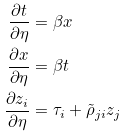<formula> <loc_0><loc_0><loc_500><loc_500>\frac { \partial t } { \partial \eta } & = \beta x \\ \frac { \partial x } { \partial \eta } & = \beta t \\ \frac { \partial { z } _ { i } } { \partial \eta } & = \tau _ { i } + \tilde { \rho } _ { j i } { z } _ { j }</formula> 